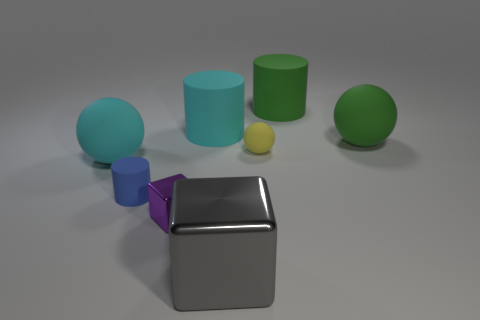Add 2 green metallic balls. How many objects exist? 10 Subtract all cubes. How many objects are left? 6 Subtract all big brown matte cylinders. Subtract all cyan matte balls. How many objects are left? 7 Add 3 small blue matte cylinders. How many small blue matte cylinders are left? 4 Add 3 big green cylinders. How many big green cylinders exist? 4 Subtract 0 brown cylinders. How many objects are left? 8 